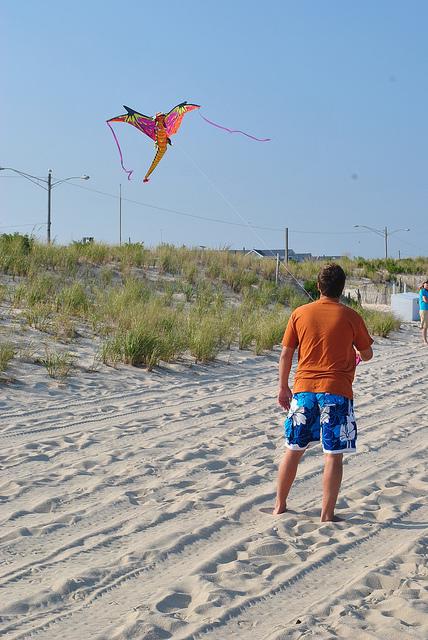Why is the man wearing swim trunks?
Quick response, please. At beach. How many balls in picture?
Write a very short answer. 0. What game is being played?
Concise answer only. Kite flying. What color is the sand?
Be succinct. Tan. Where is the man standing?
Write a very short answer. Beach. Is the man wearing a hat?
Write a very short answer. No. What is the kite shaped to look like?
Write a very short answer. Dragon. Is this man wet?
Concise answer only. No. Is the man shirtless?
Be succinct. No. 